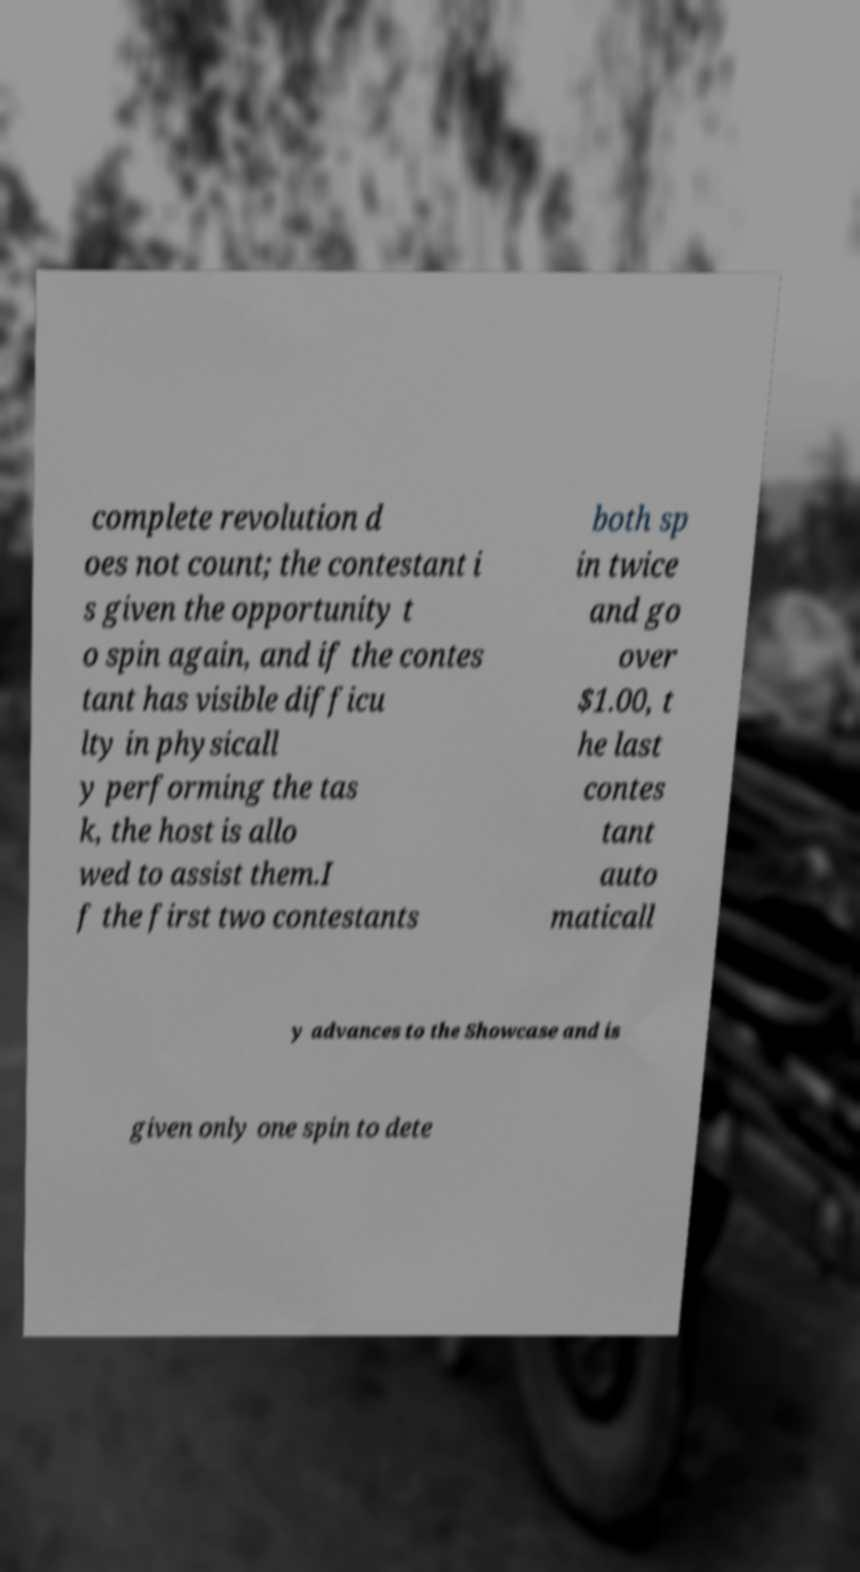Please read and relay the text visible in this image. What does it say? complete revolution d oes not count; the contestant i s given the opportunity t o spin again, and if the contes tant has visible difficu lty in physicall y performing the tas k, the host is allo wed to assist them.I f the first two contestants both sp in twice and go over $1.00, t he last contes tant auto maticall y advances to the Showcase and is given only one spin to dete 